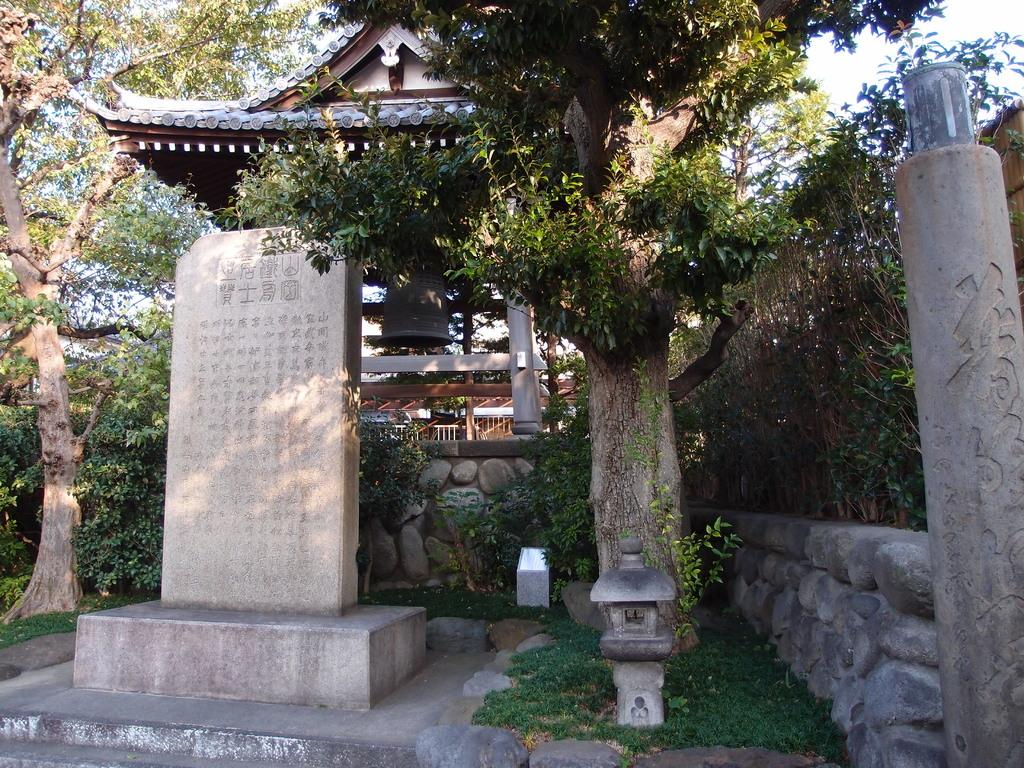What is the main object in the image? There is a stone in the image. What can be seen on the surface of the stone? The stone has symbols engraved on it. What can be seen in the distance in the image? There is a building, a group of trees, poles, and the sky visible in the background of the image. What type of hen is sitting on the stone in the image? There is no hen present in the image; it only features a stone with symbols and a background with a building, trees, poles, and the sky. 